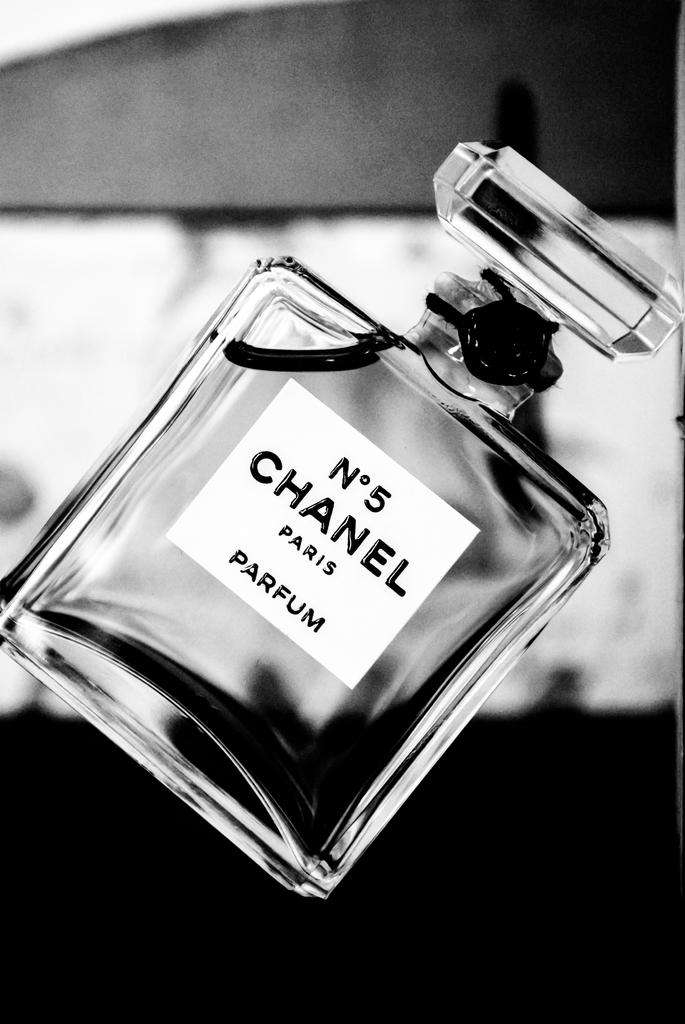<image>
Render a clear and concise summary of the photo. A bottle of Chanel number  5 parfum tilted to one side. 